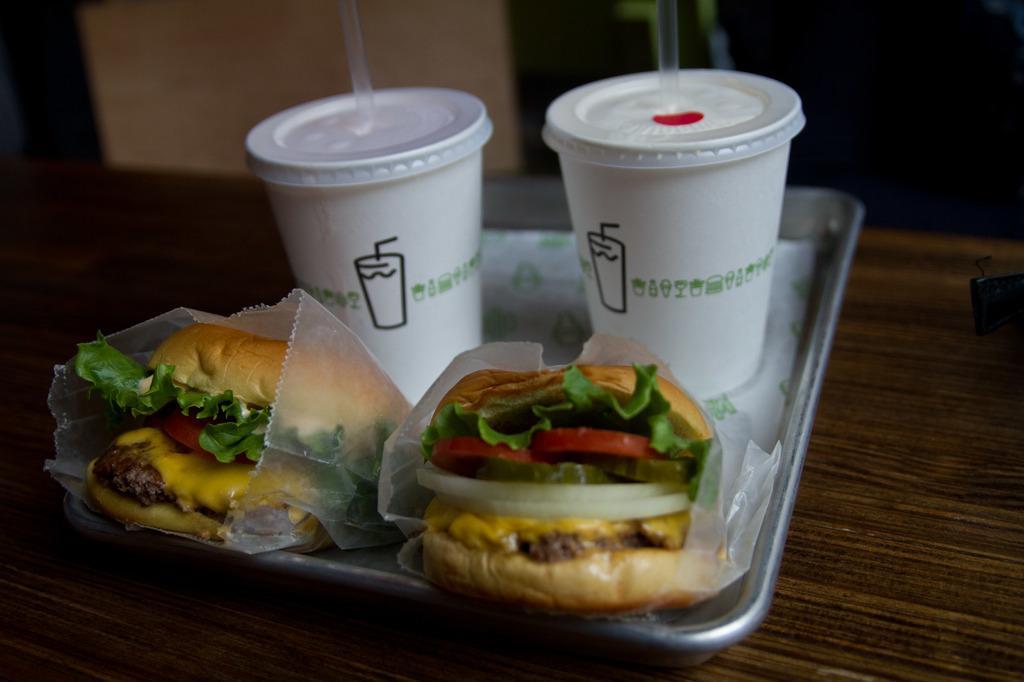Please provide a concise description of this image. In this picture I can see cups with straws and burgers on the tray, on the table, and there is blur background. 